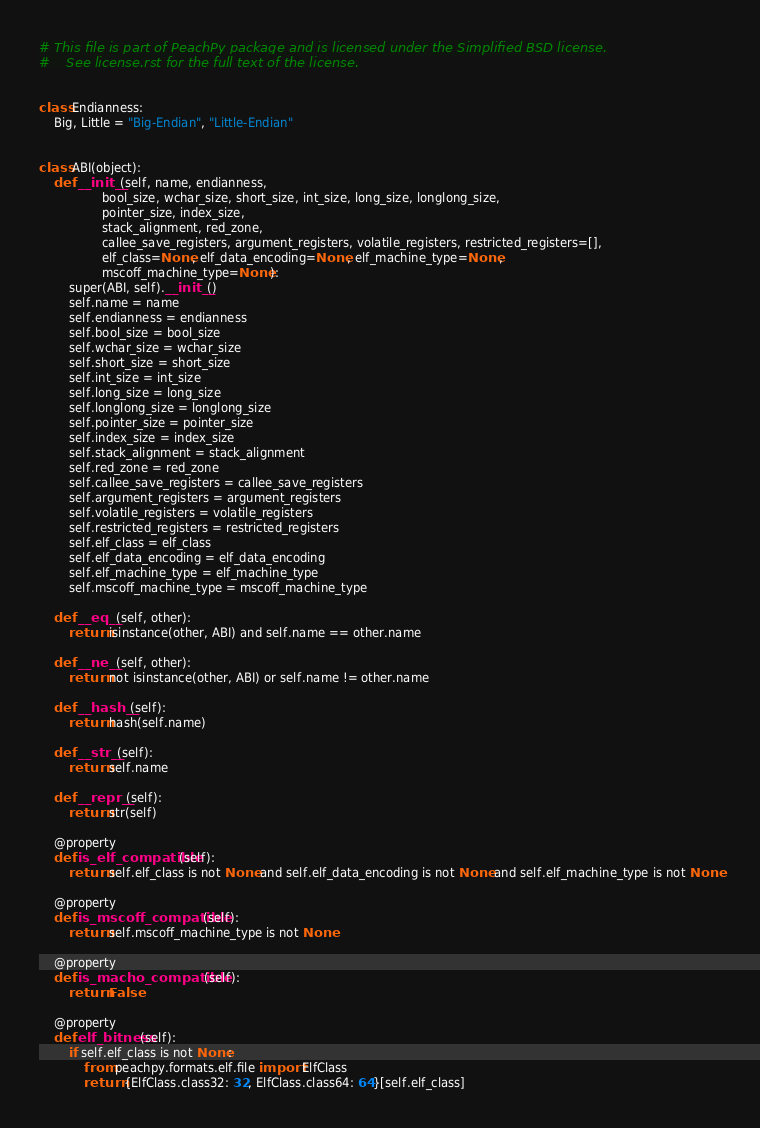Convert code to text. <code><loc_0><loc_0><loc_500><loc_500><_Python_># This file is part of PeachPy package and is licensed under the Simplified BSD license.
#    See license.rst for the full text of the license.


class Endianness:
    Big, Little = "Big-Endian", "Little-Endian"


class ABI(object):
    def __init__(self, name, endianness,
                 bool_size, wchar_size, short_size, int_size, long_size, longlong_size,
                 pointer_size, index_size,
                 stack_alignment, red_zone,
                 callee_save_registers, argument_registers, volatile_registers, restricted_registers=[],
                 elf_class=None, elf_data_encoding=None, elf_machine_type=None,
                 mscoff_machine_type=None):
        super(ABI, self).__init__()
        self.name = name
        self.endianness = endianness
        self.bool_size = bool_size
        self.wchar_size = wchar_size
        self.short_size = short_size
        self.int_size = int_size
        self.long_size = long_size
        self.longlong_size = longlong_size
        self.pointer_size = pointer_size
        self.index_size = index_size
        self.stack_alignment = stack_alignment
        self.red_zone = red_zone
        self.callee_save_registers = callee_save_registers
        self.argument_registers = argument_registers
        self.volatile_registers = volatile_registers
        self.restricted_registers = restricted_registers
        self.elf_class = elf_class
        self.elf_data_encoding = elf_data_encoding
        self.elf_machine_type = elf_machine_type
        self.mscoff_machine_type = mscoff_machine_type

    def __eq__(self, other):
        return isinstance(other, ABI) and self.name == other.name

    def __ne__(self, other):
        return not isinstance(other, ABI) or self.name != other.name

    def __hash__(self):
        return hash(self.name)

    def __str__(self):
        return self.name

    def __repr__(self):
        return str(self)

    @property
    def is_elf_compatible(self):
        return self.elf_class is not None and self.elf_data_encoding is not None and self.elf_machine_type is not None

    @property
    def is_mscoff_compatible(self):
        return self.mscoff_machine_type is not None

    @property
    def is_macho_compatible(self):
        return False

    @property
    def elf_bitness(self):
        if self.elf_class is not None:
            from peachpy.formats.elf.file import ElfClass
            return {ElfClass.class32: 32, ElfClass.class64: 64}[self.elf_class]
</code> 